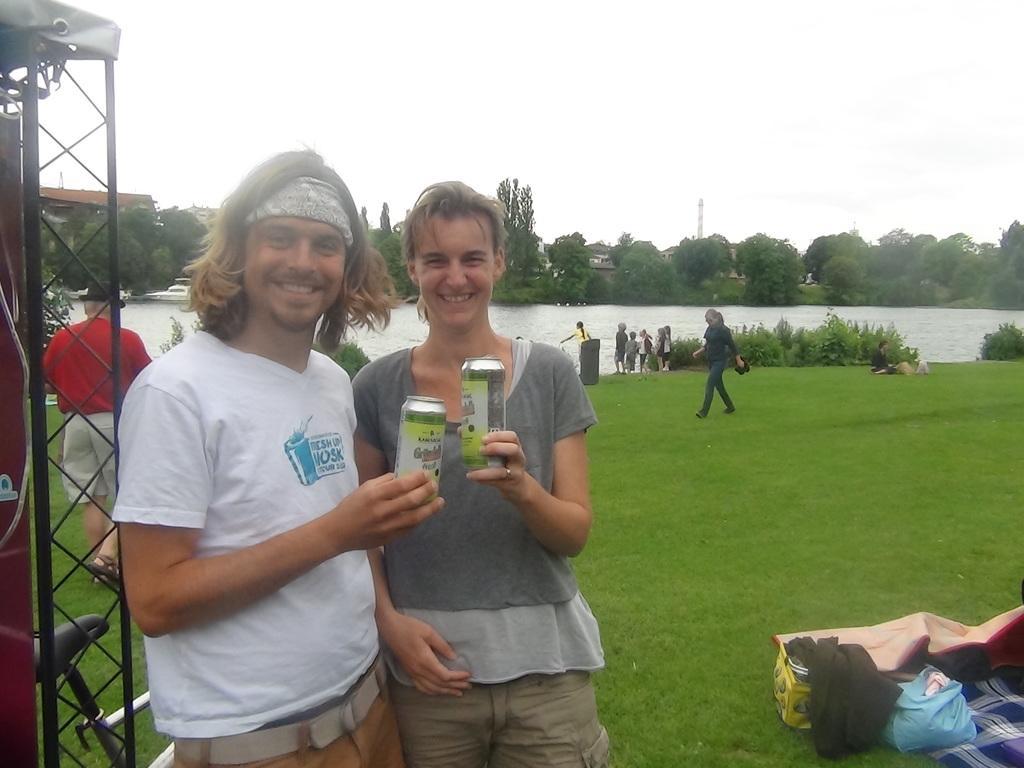Please provide a concise description of this image. In this picture we can see 2 people standing on the grass and holding cans and smiling at someone. In the background, we can see trees, river, people walking on the grass. On the left side, we can see a bicycle and an iron stand and on the right side, we can see a blanket and other things. 